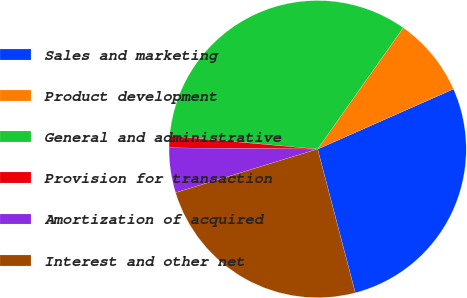<chart> <loc_0><loc_0><loc_500><loc_500><pie_chart><fcel>Sales and marketing<fcel>Product development<fcel>General and administrative<fcel>Provision for transaction<fcel>Amortization of acquired<fcel>Interest and other net<nl><fcel>27.55%<fcel>8.59%<fcel>33.36%<fcel>1.29%<fcel>4.87%<fcel>24.34%<nl></chart> 